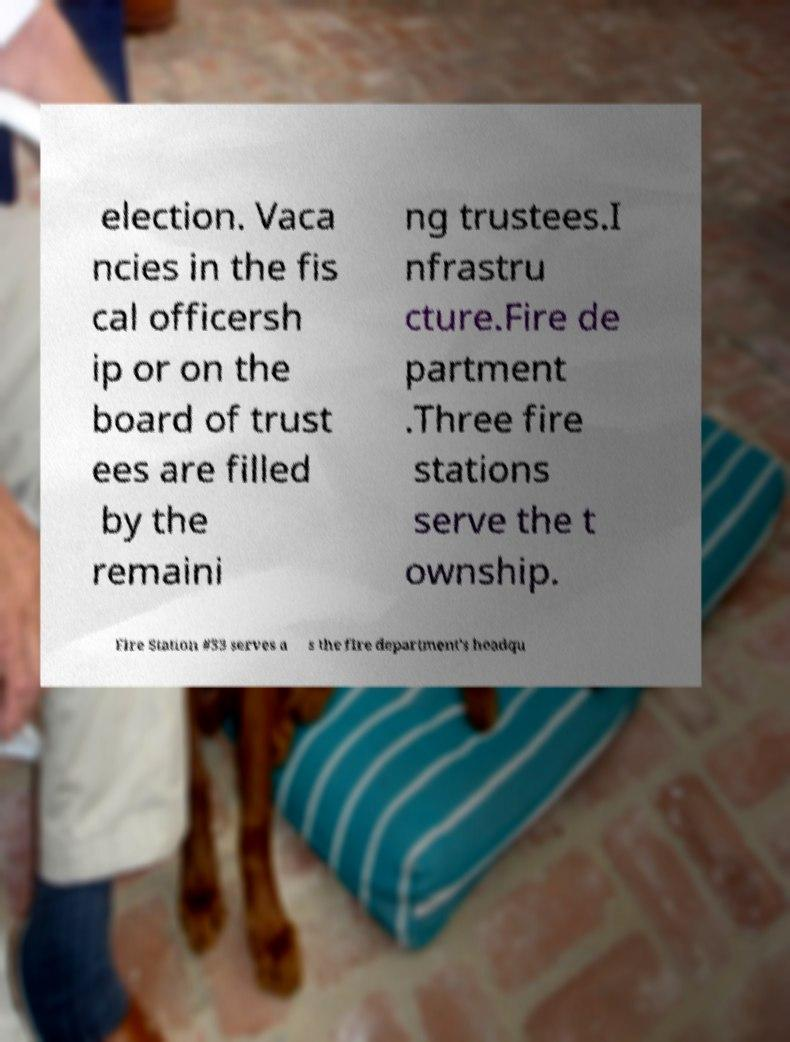For documentation purposes, I need the text within this image transcribed. Could you provide that? election. Vaca ncies in the fis cal officersh ip or on the board of trust ees are filled by the remaini ng trustees.I nfrastru cture.Fire de partment .Three fire stations serve the t ownship. Fire Station #33 serves a s the fire department's headqu 